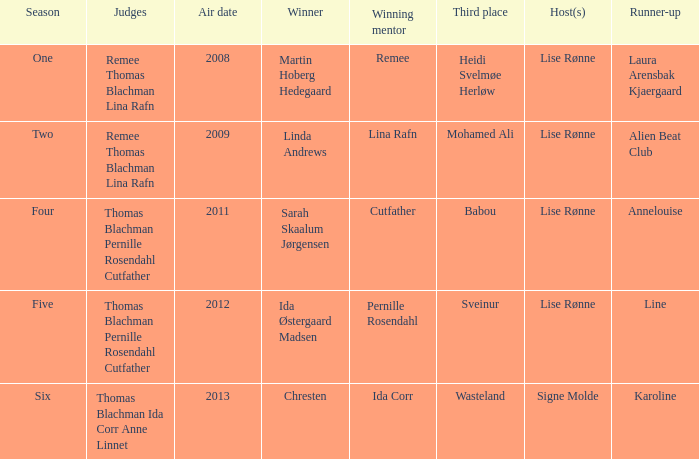Can you parse all the data within this table? {'header': ['Season', 'Judges', 'Air date', 'Winner', 'Winning mentor', 'Third place', 'Host(s)', 'Runner-up'], 'rows': [['One', 'Remee Thomas Blachman Lina Rafn', '2008', 'Martin Hoberg Hedegaard', 'Remee', 'Heidi Svelmøe Herløw', 'Lise Rønne', 'Laura Arensbak Kjaergaard'], ['Two', 'Remee Thomas Blachman Lina Rafn', '2009', 'Linda Andrews', 'Lina Rafn', 'Mohamed Ali', 'Lise Rønne', 'Alien Beat Club'], ['Four', 'Thomas Blachman Pernille Rosendahl Cutfather', '2011', 'Sarah Skaalum Jørgensen', 'Cutfather', 'Babou', 'Lise Rønne', 'Annelouise'], ['Five', 'Thomas Blachman Pernille Rosendahl Cutfather', '2012', 'Ida Østergaard Madsen', 'Pernille Rosendahl', 'Sveinur', 'Lise Rønne', 'Line'], ['Six', 'Thomas Blachman Ida Corr Anne Linnet', '2013', 'Chresten', 'Ida Corr', 'Wasteland', 'Signe Molde', 'Karoline']]} Who was the runner-up in season five? Line. 